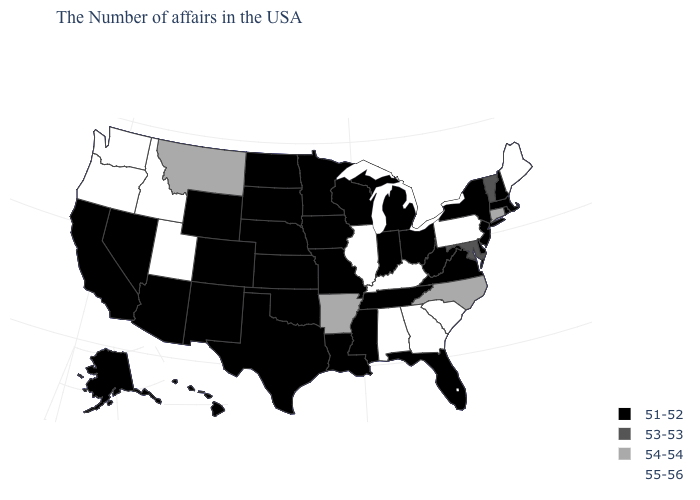What is the value of Idaho?
Quick response, please. 55-56. What is the value of Rhode Island?
Answer briefly. 51-52. Which states have the lowest value in the USA?
Give a very brief answer. Massachusetts, Rhode Island, New Hampshire, New York, New Jersey, Delaware, Virginia, West Virginia, Ohio, Florida, Michigan, Indiana, Tennessee, Wisconsin, Mississippi, Louisiana, Missouri, Minnesota, Iowa, Kansas, Nebraska, Oklahoma, Texas, South Dakota, North Dakota, Wyoming, Colorado, New Mexico, Arizona, Nevada, California, Alaska, Hawaii. Name the states that have a value in the range 54-54?
Be succinct. Connecticut, North Carolina, Arkansas, Montana. Name the states that have a value in the range 54-54?
Answer briefly. Connecticut, North Carolina, Arkansas, Montana. What is the highest value in the MidWest ?
Answer briefly. 55-56. Does Pennsylvania have a higher value than Michigan?
Quick response, please. Yes. Does Vermont have the same value as Maryland?
Give a very brief answer. Yes. Among the states that border Mississippi , which have the lowest value?
Be succinct. Tennessee, Louisiana. What is the value of North Carolina?
Answer briefly. 54-54. Name the states that have a value in the range 53-53?
Be succinct. Vermont, Maryland. Does North Carolina have the highest value in the USA?
Short answer required. No. What is the lowest value in the USA?
Answer briefly. 51-52. Among the states that border Illinois , does Iowa have the highest value?
Give a very brief answer. No. What is the lowest value in the Northeast?
Concise answer only. 51-52. 